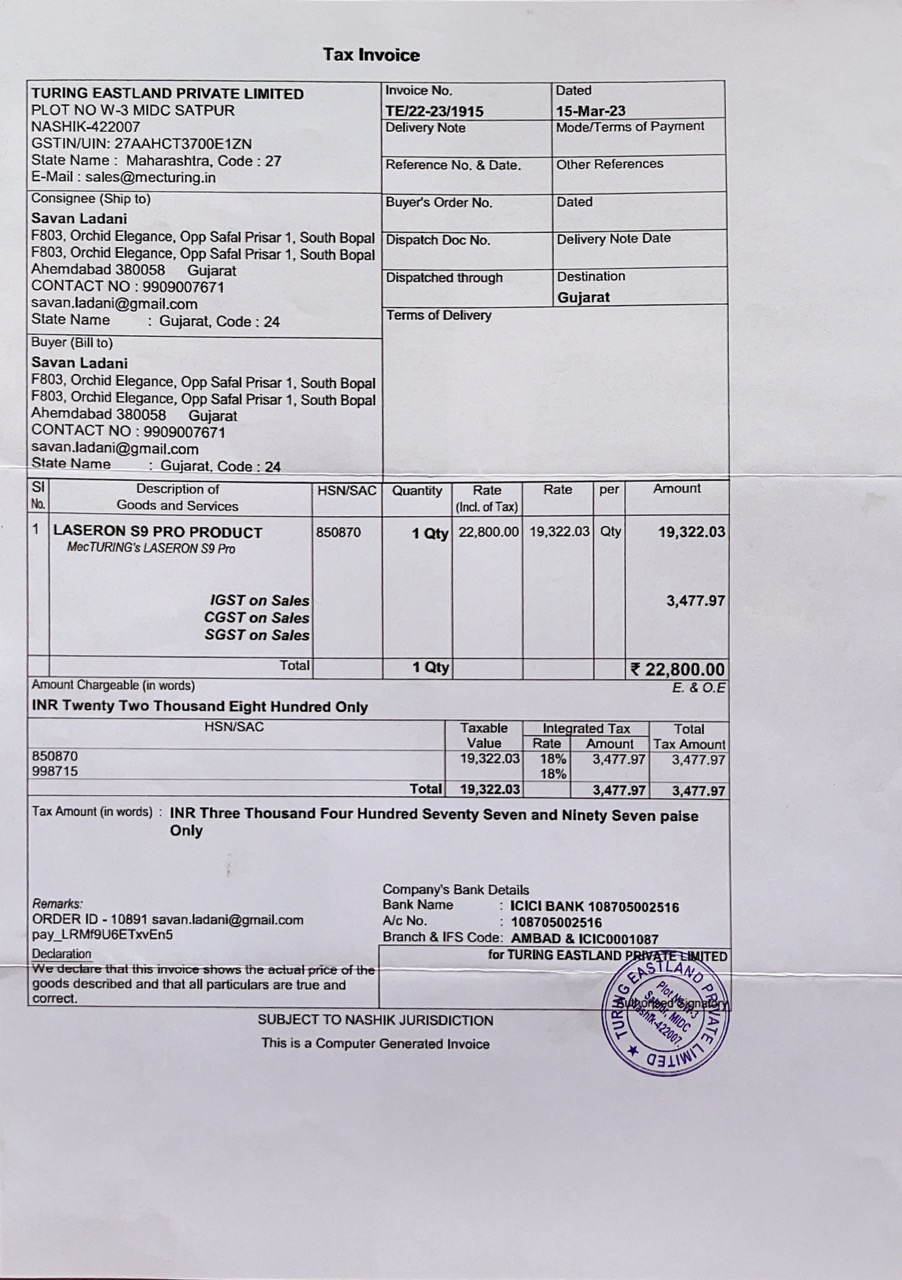what is the invoice total amount? According to the tax invoice, the total amount chargeable is INR 22,800.00 (Twenty Two Thousand Eight Hundred Only). 